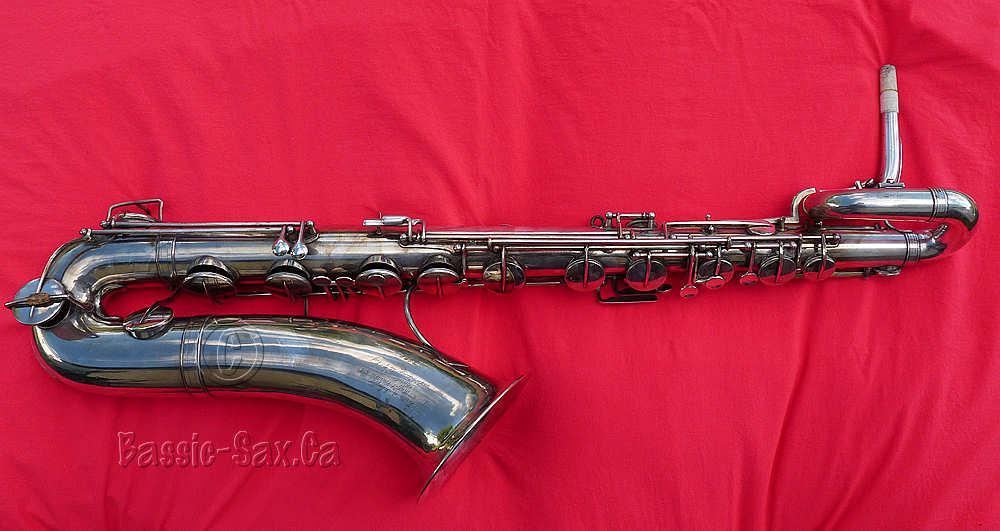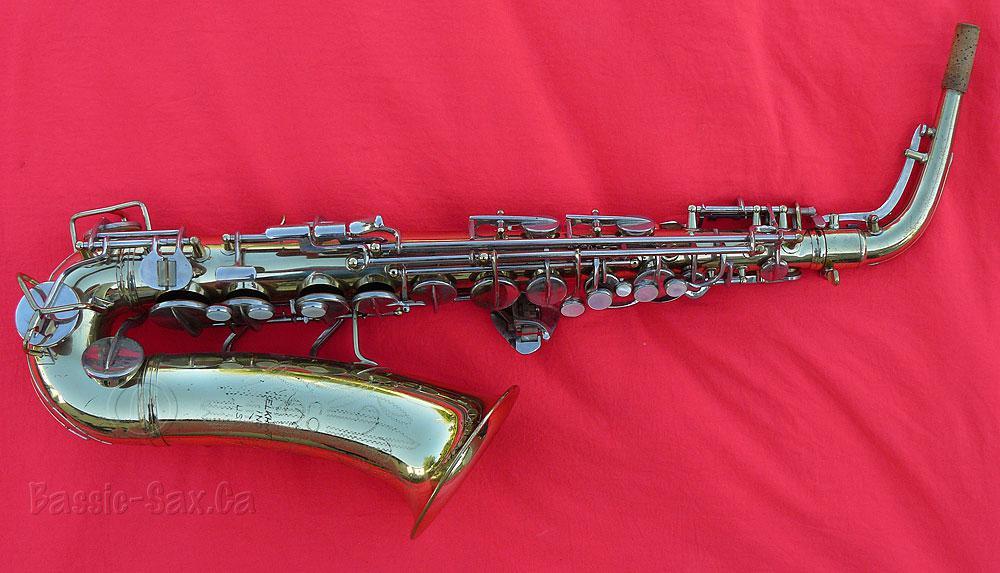The first image is the image on the left, the second image is the image on the right. Assess this claim about the two images: "Saxophones displayed in the left and right images are positioned in the same way and facing same direction.". Correct or not? Answer yes or no. Yes. The first image is the image on the left, the second image is the image on the right. Given the left and right images, does the statement "The saxophones are positioned in the same way on the red blanket." hold true? Answer yes or no. Yes. 